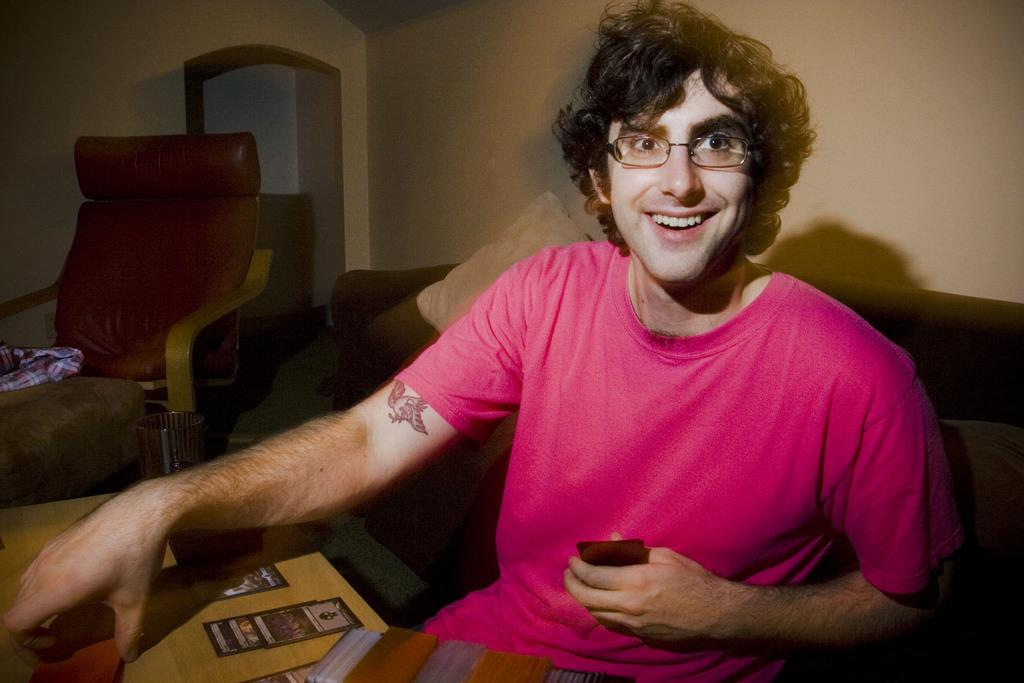What is the person in the image doing? The person is sitting on a chair in the image. Can you describe the type of chair the person is sitting on? The chair is described as a sofa chair. What is the person holding in his hand? The person is holding an object in his hand. What type of drink is the person starting to consume in the image? There is no drink present in the image, and the person is not starting to consume anything. 